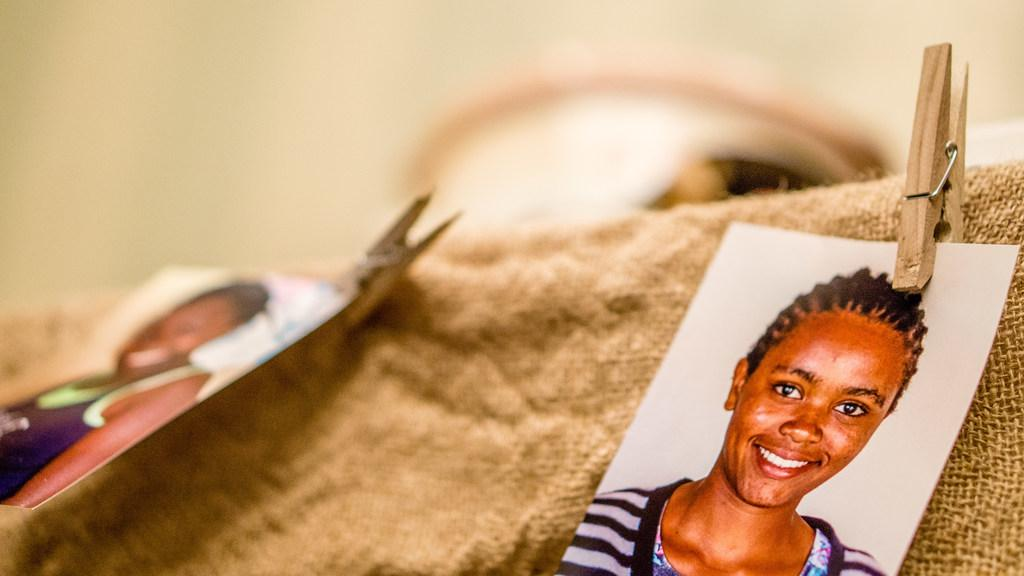What object is present in the image that is typically used to hold things together? There is a clip in the image. What type of photo can be seen in the image? There is a passport size photo in the image. What material is visible in the image? There is cloth in the image. How would you describe the focus of the image? The left side and background of the image are blurred. What type of owl can be seen sitting on the cloth in the image? There is no owl present in the image; it only features a clip, passport size photo, and cloth. How does the cloth provide comfort in the image? The image does not depict the cloth providing comfort, as it is not interacting with any person or object in a way that suggests comfort. 